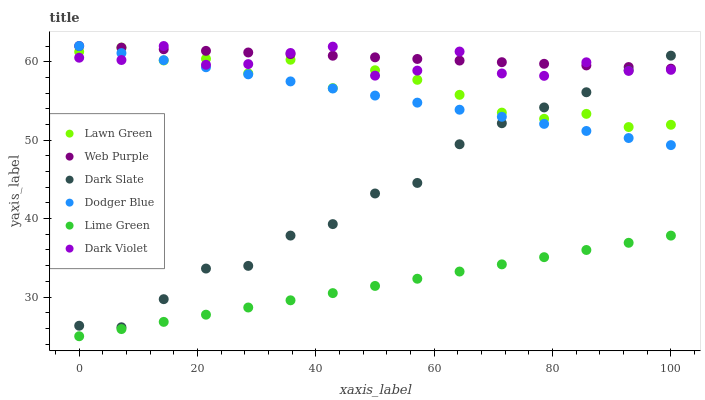Does Lime Green have the minimum area under the curve?
Answer yes or no. Yes. Does Web Purple have the maximum area under the curve?
Answer yes or no. Yes. Does Dark Violet have the minimum area under the curve?
Answer yes or no. No. Does Dark Violet have the maximum area under the curve?
Answer yes or no. No. Is Web Purple the smoothest?
Answer yes or no. Yes. Is Dark Violet the roughest?
Answer yes or no. Yes. Is Dark Slate the smoothest?
Answer yes or no. No. Is Dark Slate the roughest?
Answer yes or no. No. Does Lime Green have the lowest value?
Answer yes or no. Yes. Does Dark Violet have the lowest value?
Answer yes or no. No. Does Dodger Blue have the highest value?
Answer yes or no. Yes. Does Dark Slate have the highest value?
Answer yes or no. No. Is Lime Green less than Lawn Green?
Answer yes or no. Yes. Is Lawn Green greater than Lime Green?
Answer yes or no. Yes. Does Dark Slate intersect Web Purple?
Answer yes or no. Yes. Is Dark Slate less than Web Purple?
Answer yes or no. No. Is Dark Slate greater than Web Purple?
Answer yes or no. No. Does Lime Green intersect Lawn Green?
Answer yes or no. No. 